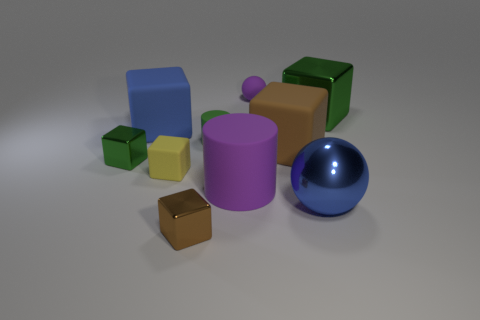How many objects are visible in the image, and can you name their shapes? There are eight objects in the image. Starting from the left, there is a blue cube, a small yellow cube, a purple cylinder, a small green cube, a large green cube, a blue sphere, a small brown cube, and a purple sphere. 